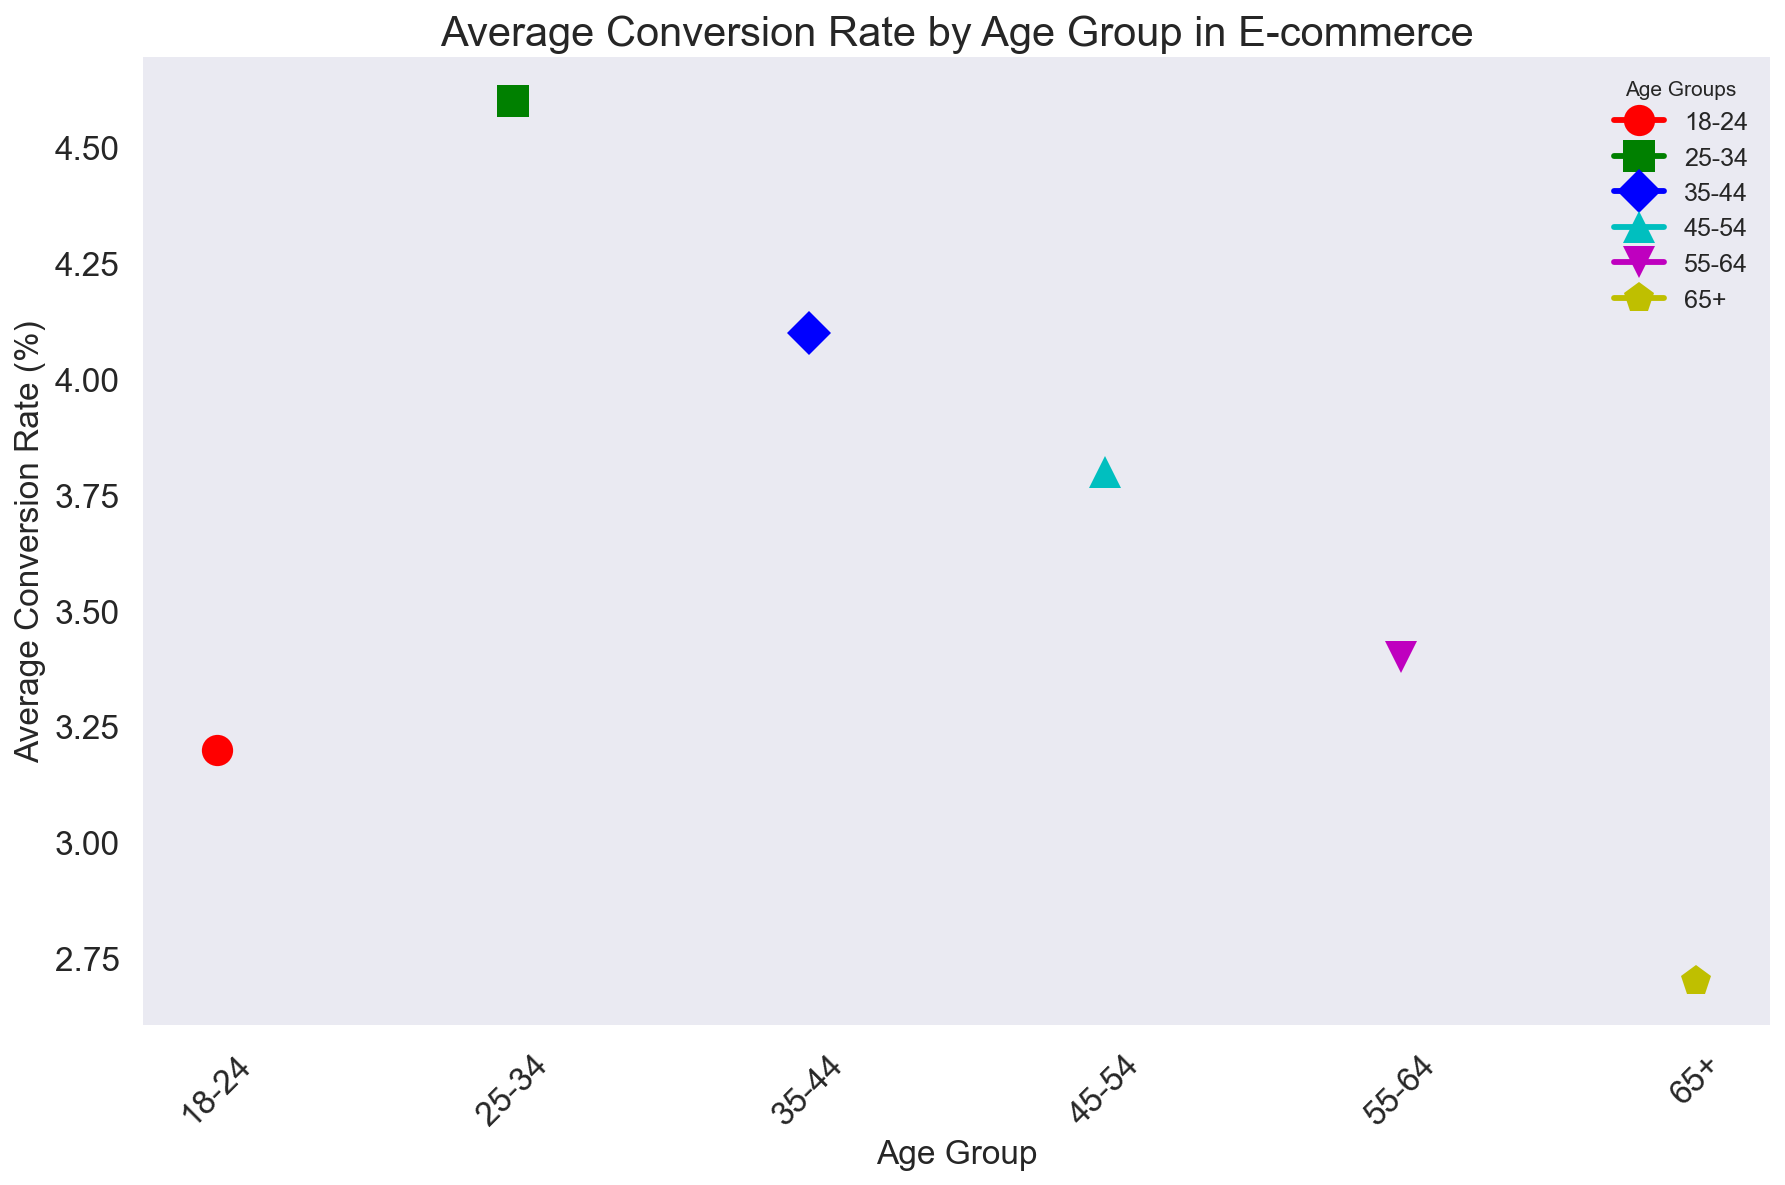What's the average conversion rate for the 25-34 and 35-44 age groups? First, identify the average conversion rates for the 25-34 and 35-44 age groups, which are 4.6% and 4.1%, respectively. Sum these values to get 4.6 + 4.1 = 8.7%. Then, divide this sum by 2 to find the average, so 8.7 / 2 = 4.35%.
Answer: 4.35% Which age group has the highest conversion rate? By visually scanning the heights of the markers representing conversion rates, the 25-34 age group has the highest marker position, indicating its conversion rate of 4.6%.
Answer: 25-34 Among the 55-64 and 65+ age groups, which one has a lower conversion rate? Compare the heights of the markers representing the conversion rates for the 55-64 and 65+ age groups. The 55-64 age group has a higher marker at 3.4%, while the 65+ age group is lower at 2.7%.
Answer: 65+ Which age group is represented by a green marker? By visually identifying the colors, the green marker corresponds to the 25-34 age group.
Answer: 25-34 What's the difference in conversion rate between the 45-54 and 65+ age groups? Identify the conversion rates for the 45-54 and 65+ age groups, which are 3.8% and 2.7% respectively. Subtract 2.7 from 3.8 to get the difference, so 3.8 - 2.7 = 1.1%.
Answer: 1.1% How many age groups have a conversion rate higher than 4%? Visually scan the markers and identify the age groups with conversion rates above the 4% threshold. The age groups 25-34 and 35-44 are above this level.
Answer: 2 Which color is used for the 18-24 age group marker? By identifying the color of the marker corresponding to the 18-24 age group visually, it is red.
Answer: red Is the conversion rate for the 35-44 age group higher than that for the 55-64 age group? Compare the heights of the markers representing conversion rates and note that the 35-44 age group has a conversion rate of 4.1%, while the 55-64 age group is at 3.4%. Thus, 4.1% is indeed higher than 3.4%.
Answer: Yes 